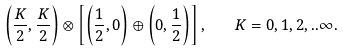<formula> <loc_0><loc_0><loc_500><loc_500>\left ( \frac { K } { 2 } , \frac { K } { 2 } \right ) \otimes \left [ \left ( \frac { 1 } { 2 } , 0 \right ) \oplus \left ( 0 , \frac { 1 } { 2 } \right ) \right ] , \quad K = 0 , 1 , 2 , . . \infty .</formula> 